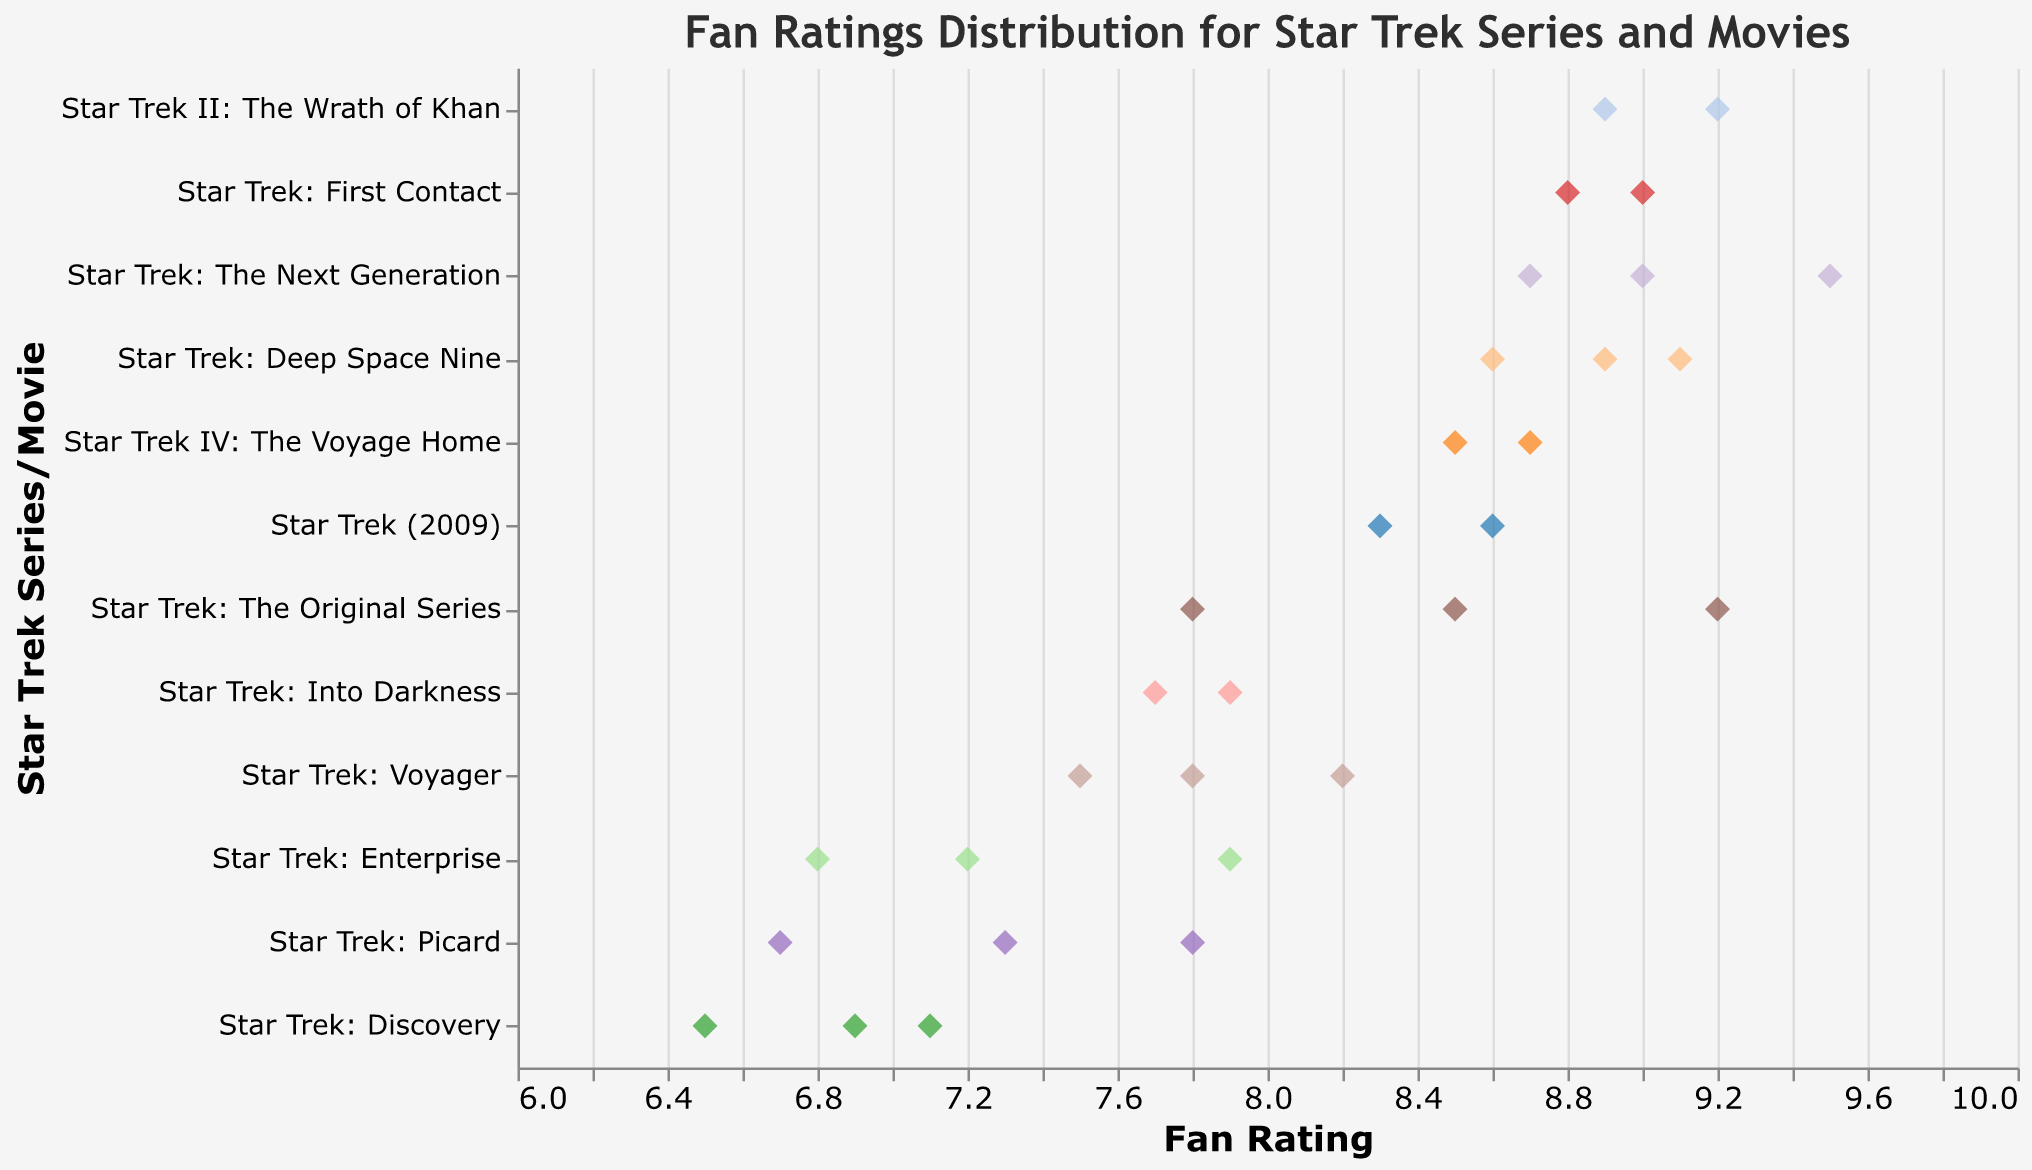What is the highest fan rating for "Star Trek: The Next Generation"? Identify the data points corresponding to "Star Trek: The Next Generation" and check the ratings. The highest rating is 9.5.
Answer: 9.5 Which series or movie has the lowest fan rating? Observe the plot to find the lowest point on the x-axis. "Star Trek: Discovery" has the lowest rating of 6.5.
Answer: Star Trek: Discovery What is the average rating for "Star Trek: Deep Space Nine"? The ratings for "Star Trek: Deep Space Nine" are 8.9, 9.1, and 8.6. Sum these values (8.9 + 9.1 + 8.6 = 26.6) and divide by the number of ratings (26.6 / 3 = 8.87).
Answer: 8.87 How does the range of ratings for "Star Trek: Voyager" compare to "Star Trek: Enterprise"? "Star Trek: Voyager" has ratings ranging from 7.5 to 8.2, a range of 8.2 - 7.5 = 0.7. "Star Trek: Enterprise" has ratings from 6.8 to 7.9, a range of 7.9 - 6.8 = 1.1. The range for "Enterprise" is larger.
Answer: The range for "Enterprise" is larger Which Star Trek movie received the highest individual fan rating? Check all the data points corresponding to Star Trek movies and find the highest rating. "Star Trek: The Next Generation" has the highest rating of 9.5.
Answer: Star Trek: The Next Generation How many series or movies have at least one rating above 9.0? Count the series or movies with at least one data point above the 9.0 mark. These are "Star Trek: The Original Series," "Star Trek: The Next Generation," "Star Trek: Deep Space Nine," and "Star Trek II: The Wrath of Khan."
Answer: 4 Compare the lowest rating of "Star Trek: Discovery" and "Star Trek: Picard." Which has a lower rating, and by how much? "Star Trek: Discovery" has a lowest rating of 6.5, and "Star Trek: Picard" has a lowest rating of 6.7. The difference is 6.7 - 6.5 = 0.2.
Answer: Star Trek: Discovery by 0.2 What is the median rating for "Star Trek (2009)"? The ratings are 8.3 and 8.6. The median of two numbers is the average, so (8.3 + 8.6) / 2 = 8.45.
Answer: 8.45 What is the difference between the highest ratings of "Star Trek: The Original Series" and "Star Trek: Into Darkness"? The highest rating for "Star Trek: The Original Series" is 9.2, and for "Star Trek: Into Darkness," it's 7.9. The difference is 9.2 - 7.9 = 1.3.
Answer: 1.3 